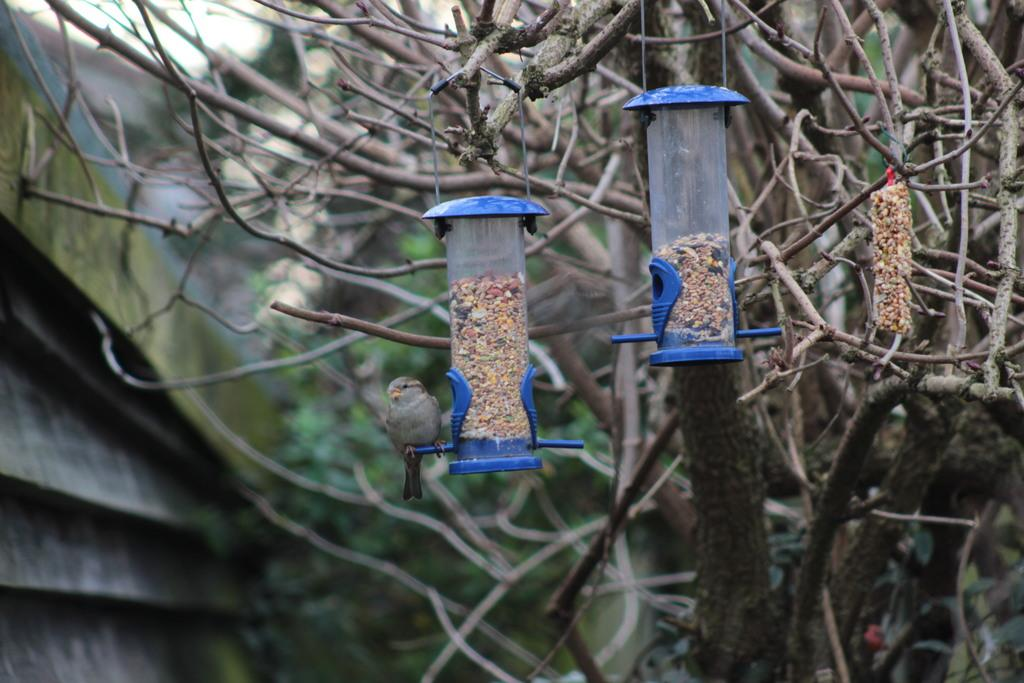What can be seen in the image related to feeding birds? There are bird seed feeders in the image. Are there any birds present in the image? Yes, there is a bird in the image. What type of natural element is visible in the image? There is a tree in the image. How would you describe the background of the image? The background of the image is blurred. What can be seen in the distance in the image? There are trees and a building in the background of the image. What type of wool is being used to mark the bird in the image? There is no wool or marking visible on the bird in the image. What rule is being enforced by the bird in the image? There is no rule being enforced by the bird in the image. 